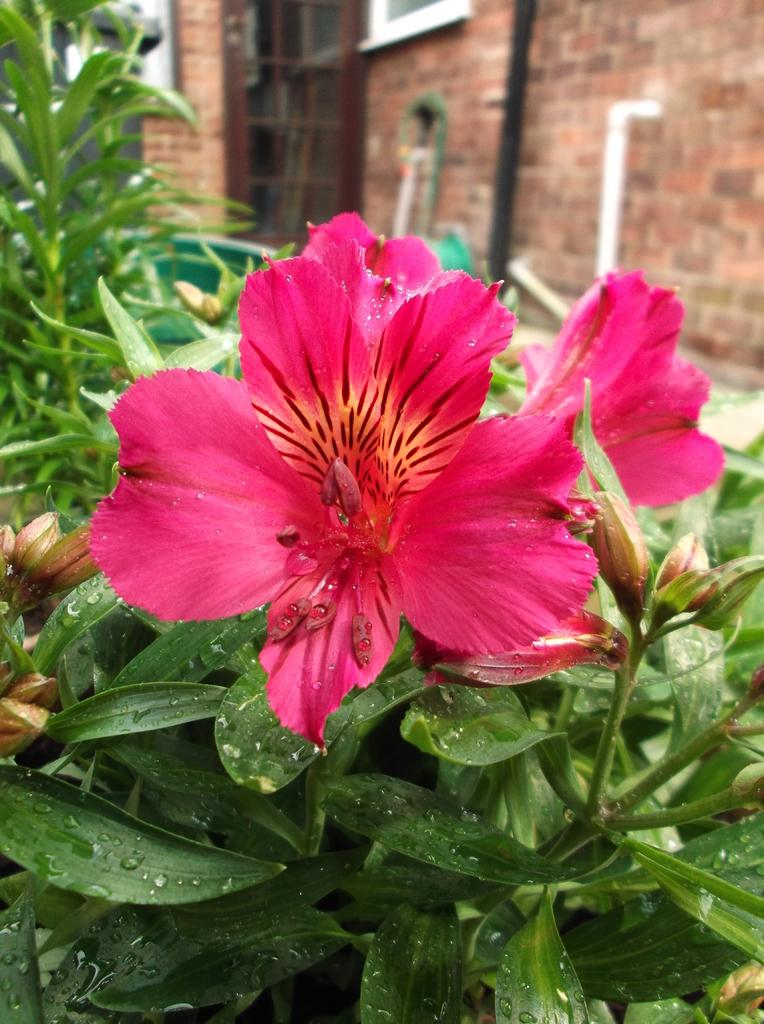What type of flora can be seen in the image? There are flowers and plants in the image. Can you describe the setting in which the flowers and plants are located? The image shows a building wall visible at the top, suggesting that the flowers and plants are in an urban environment. Are there any visible fangs on the flowers in the image? There are no fangs present on the flowers in the image, as flowers do not have fangs. 